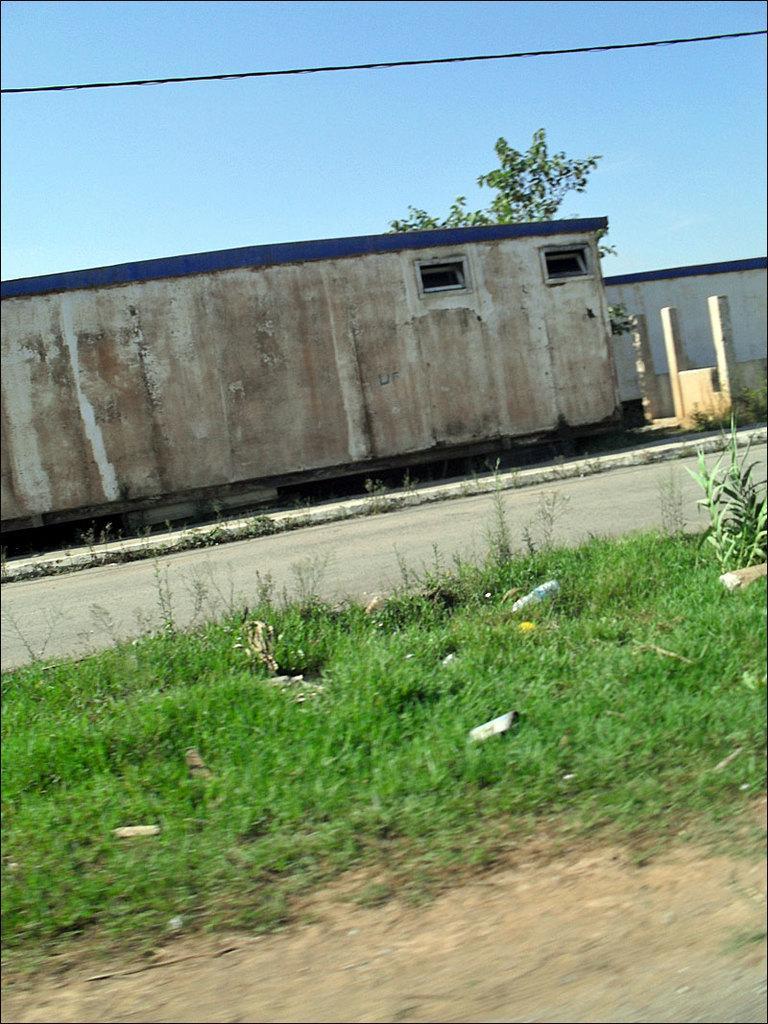How would you summarize this image in a sentence or two? In the image there is a grass on the land in the front followed by a road beside it and a building in the background with a tree behind it and above its sky. 